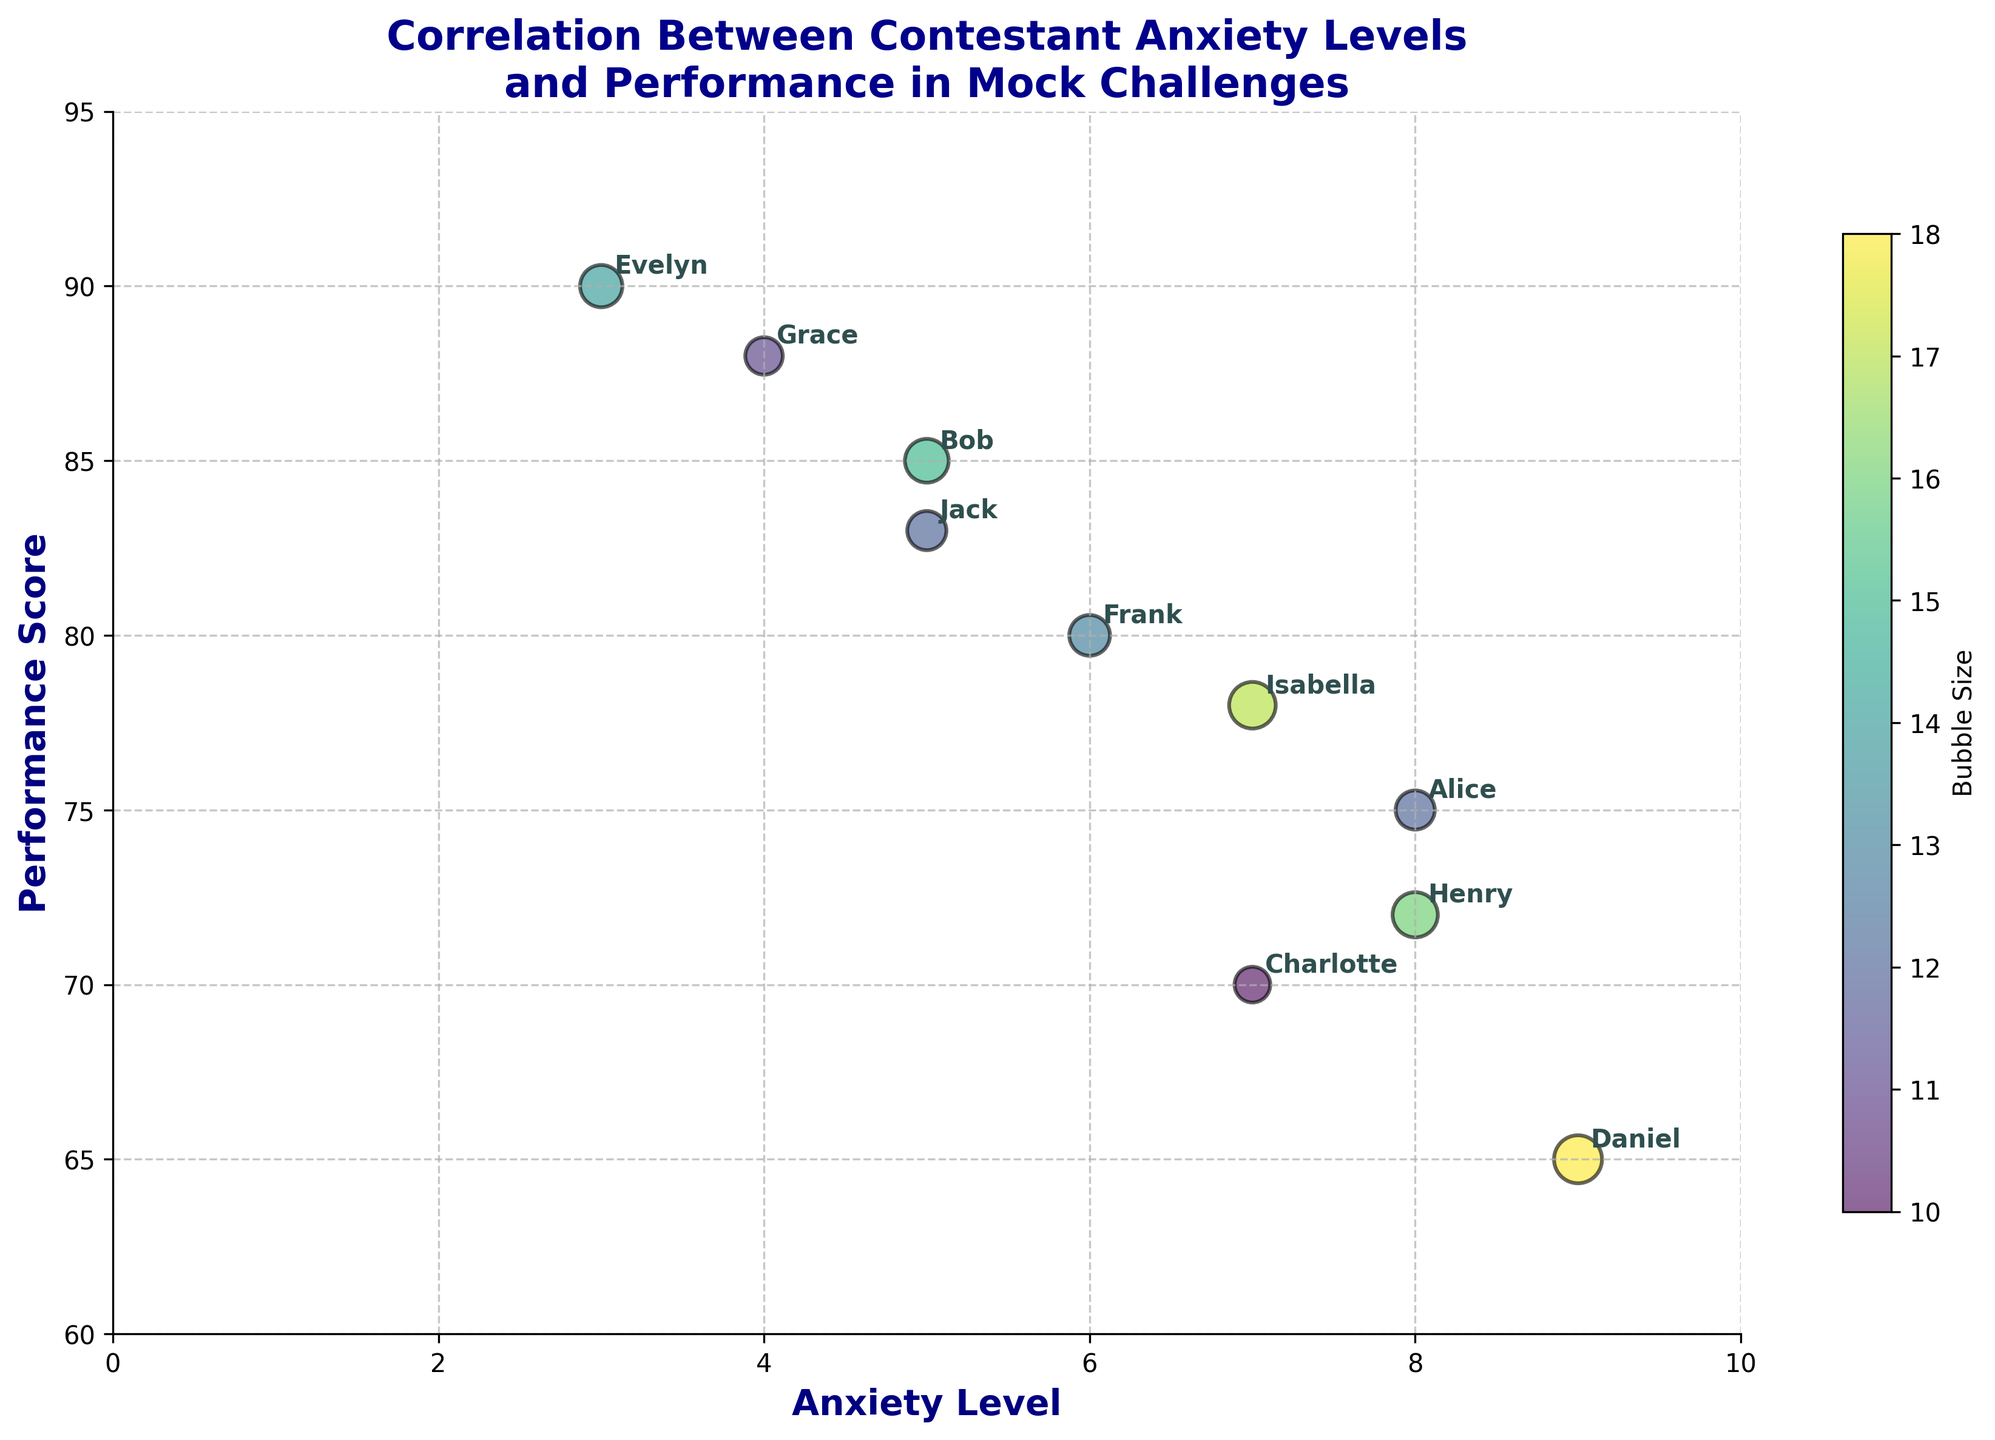How many contestants are displayed on the chart? Count the number of data points (bubbles) labeled in the chart. Here, each bubble represents a contestant. There are 10 such bubbles labeled from Alice to Jack.
Answer: 10 What is the title of the chart? Look at the title text displayed at the top of the chart. It reads "Correlation Between Contestant Anxiety Levels and Performance in Mock Challenges".
Answer: Correlation Between Contestant Anxiety Levels and Performance in Mock Challenges What is the range of Anxiety Level on the x-axis? Examine the x-axis to find the minimum and maximum values labeled. The x-axis ranges from 0 to 10.
Answer: 0 to 10 Which contestant has the highest performance score? Identify the bubble positioned highest on the y-axis, representing the Performance Score. Evelyn has the highest performance score at 90.
Answer: Evelyn Which contestant has the lowest anxiety level? Find the bubble positioned closest to the left side of the x-axis, representing the Anxiety Level. Evelyn has the lowest anxiety level at 3.
Answer: Evelyn Which contestant has the largest bubble size? Look at the bubbles and their annotations. The bubble with the largest size is Daniel. The larger the bubble, the higher the Bubble Size value.
Answer: Daniel How does Performance Score generally trend with Anxiety Level? Observe the general direction of the bubbles from left to right. As Anxiety Level increases, Performance Score tends to decrease, displaying an inverse relationship.
Answer: Inverse relationship What are the average performance scores of contestants with an Anxiety Level of 5? Locate the contestants with an Anxiety Level of 5, which are Bob and Jack. Calculate the average of their Performance Scores: (85 + 83) / 2 = 84.
Answer: 84 Which contestant has a higher performance score: Alice or Isabella? Compare the positions of Alice's and Isabella's bubbles on the y-axis. Alice's score is 75, while Isabella's score is 78. Isabella has the higher performance score.
Answer: Isabella What is the median Performance Score among all contestants? Arrange the performance scores in ascending order and find the middle value. The scores are: 65, 70, 72, 75, 78, 80, 83, 85, 88, 90. The median is the average of the 5th and 6th values: (78 + 80) / 2 = 79.
Answer: 79 